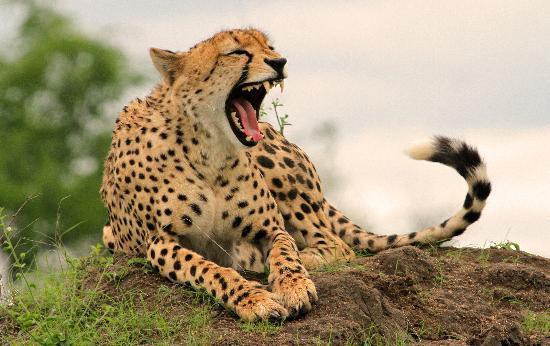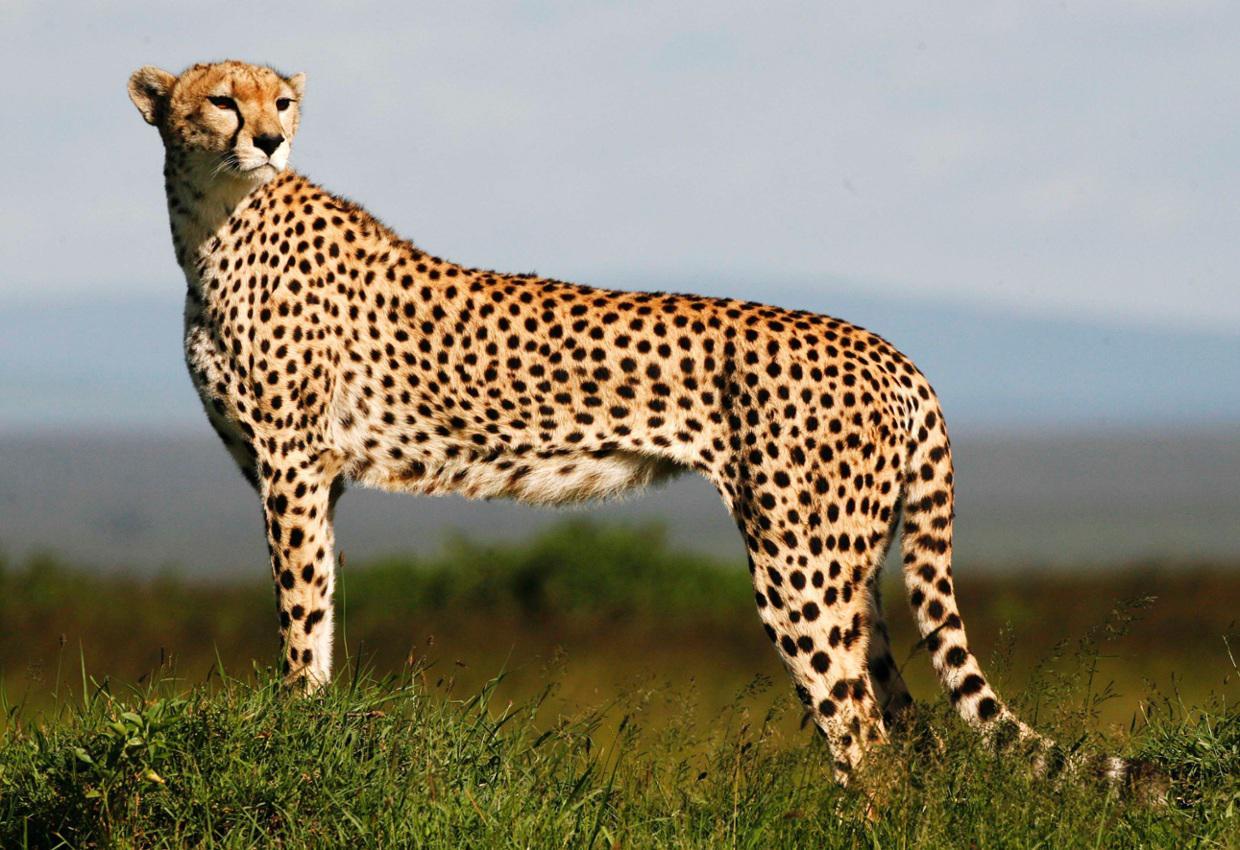The first image is the image on the left, the second image is the image on the right. Analyze the images presented: Is the assertion "At least one cheetah is laying on a mound." valid? Answer yes or no. Yes. The first image is the image on the left, the second image is the image on the right. Examine the images to the left and right. Is the description "There is at least one cheetah atop a grassy mound" accurate? Answer yes or no. Yes. 